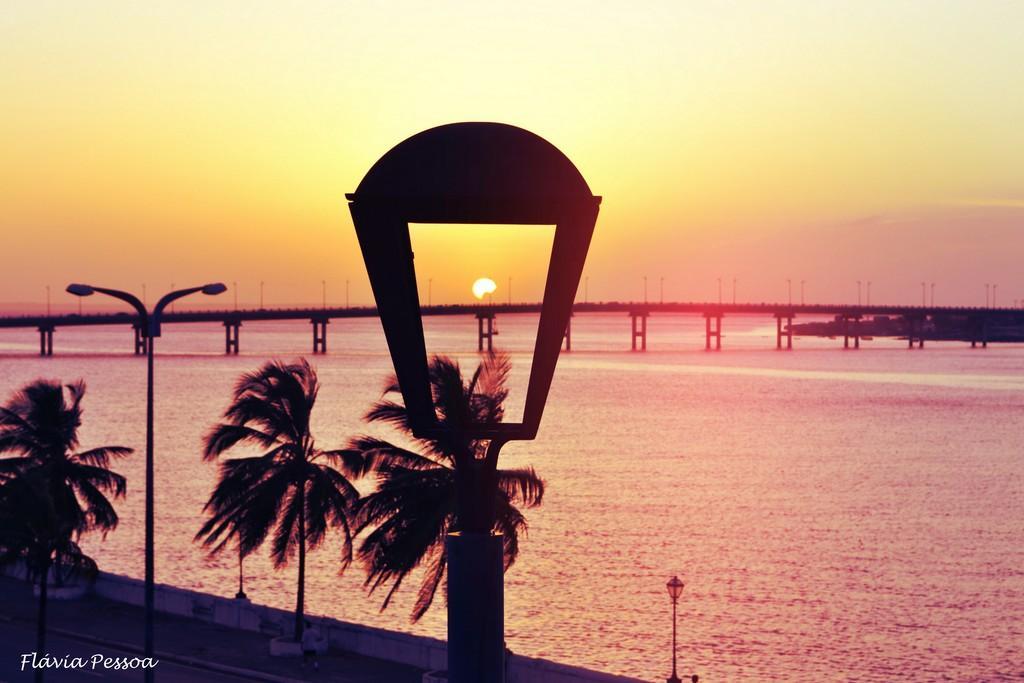Describe this image in one or two sentences. In this image there are trees, lights, poles, bridge, water, and in the background there is sky and a watermark on the image. 